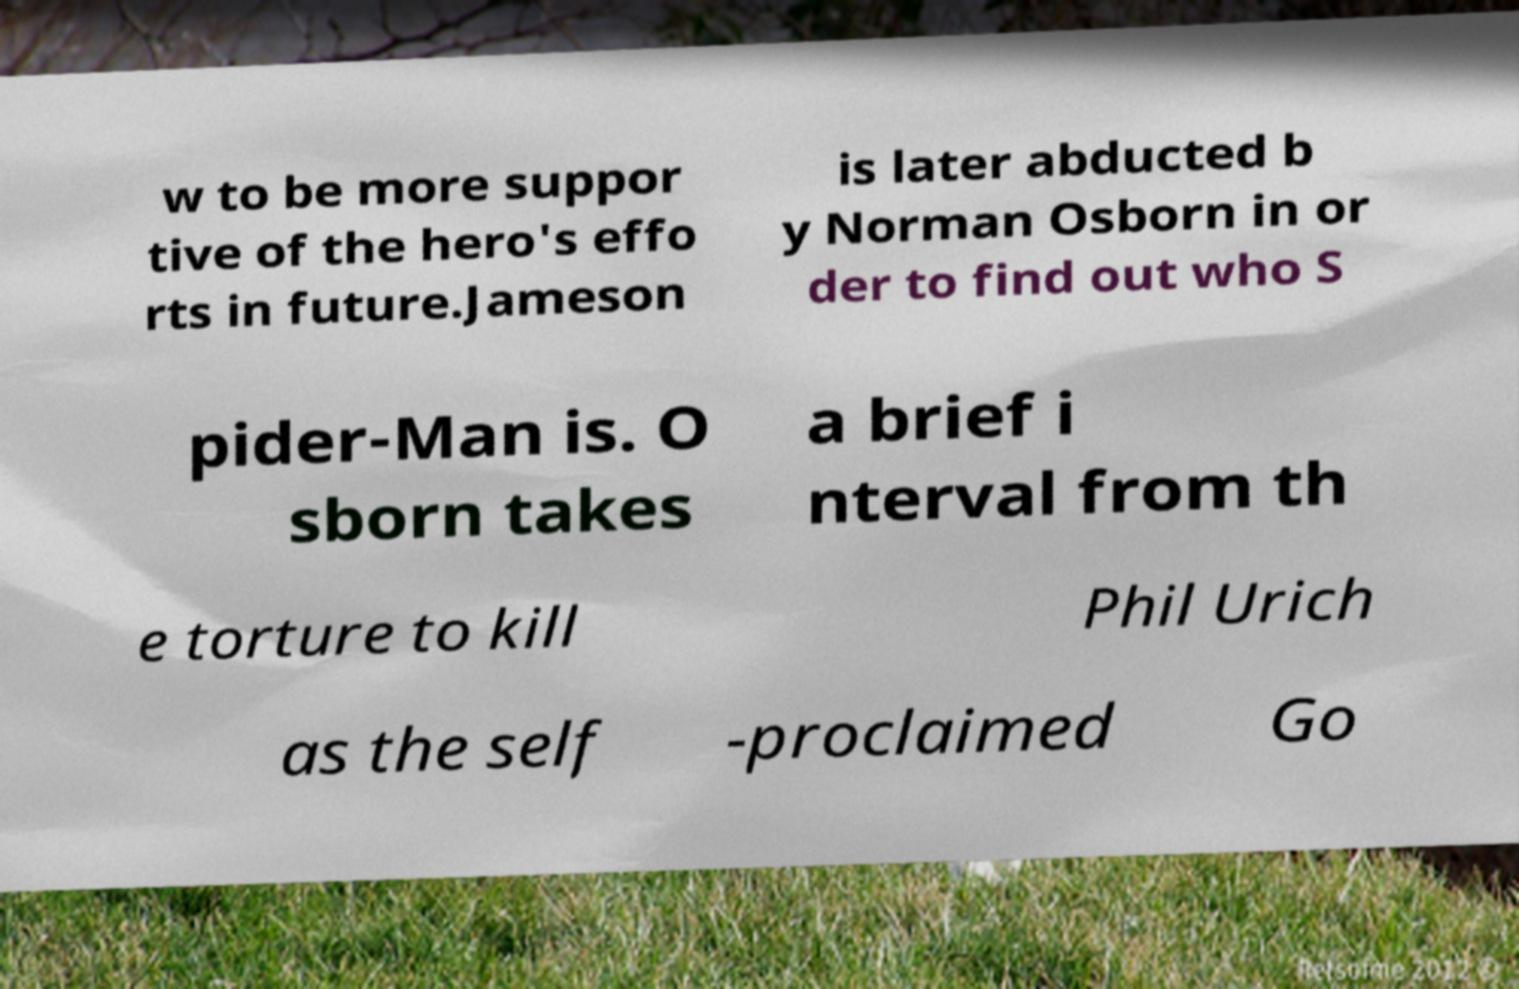There's text embedded in this image that I need extracted. Can you transcribe it verbatim? w to be more suppor tive of the hero's effo rts in future.Jameson is later abducted b y Norman Osborn in or der to find out who S pider-Man is. O sborn takes a brief i nterval from th e torture to kill Phil Urich as the self -proclaimed Go 